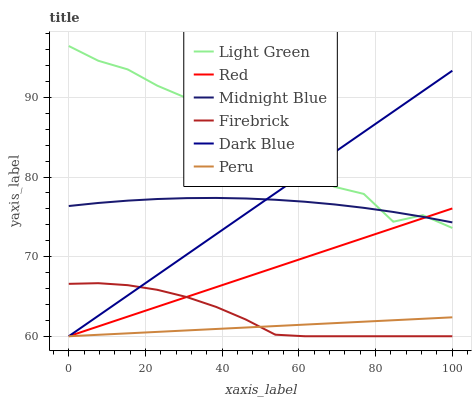Does Firebrick have the minimum area under the curve?
Answer yes or no. No. Does Firebrick have the maximum area under the curve?
Answer yes or no. No. Is Firebrick the smoothest?
Answer yes or no. No. Is Firebrick the roughest?
Answer yes or no. No. Does Midnight Blue have the lowest value?
Answer yes or no. No. Does Firebrick have the highest value?
Answer yes or no. No. Is Peru less than Light Green?
Answer yes or no. Yes. Is Midnight Blue greater than Peru?
Answer yes or no. Yes. Does Peru intersect Light Green?
Answer yes or no. No. 